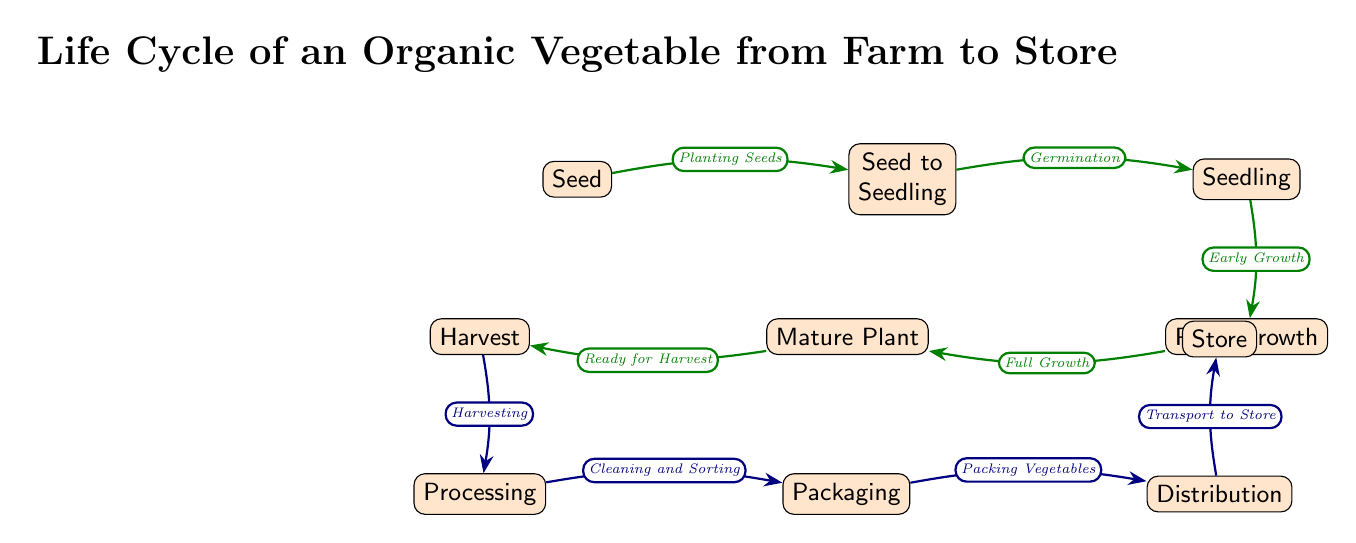What is the first step in the life cycle? The first step in the diagram is represented by the node labeled "Seed." This indicates the starting point of the organic vegetable's life cycle.
Answer: Seed How many nodes are there in the diagram? By counting all the distinct nodes in the diagram from "Seed" to "Store," we find that there are a total of 9 nodes.
Answer: 9 What is the process after "Plant Growth"? Following "Plant Growth," the next node is "Mature Plant," indicating that after the growth stage, the plant becomes mature.
Answer: Mature Plant What step occurs just before "Packaging"? The step that occurs immediately before "Packaging" is "Processing." This shows that vegetables need to be processed before they can be packaged.
Answer: Processing What is the final destination of the organic vegetables? The final destination in the life cycle depicted is the "Store," where the organic vegetables are sold to consumers.
Answer: Store What action is taken during the "Harvest" stage? During the "Harvest" stage, the action taken is "Harvesting," indicating that the mature plants are collected from the field.
Answer: Harvesting Which phase includes cleaning and sorting? The phase that involves cleaning and sorting is "Processing." This step follows the harvest to prepare the vegetables for sale.
Answer: Processing In what order do "Distribution" and "Packaging" appear? "Packaging" occurs first, followed by "Distribution," representing the sequence in which vegetables are packed and then transported to stores.
Answer: Packaging, Distribution What label indicates the readiness of the plant for harvest? The readiness of the plant for harvest is indicated by the label "Ready for Harvest," which is associated with the "Mature Plant" node.
Answer: Ready for Harvest 